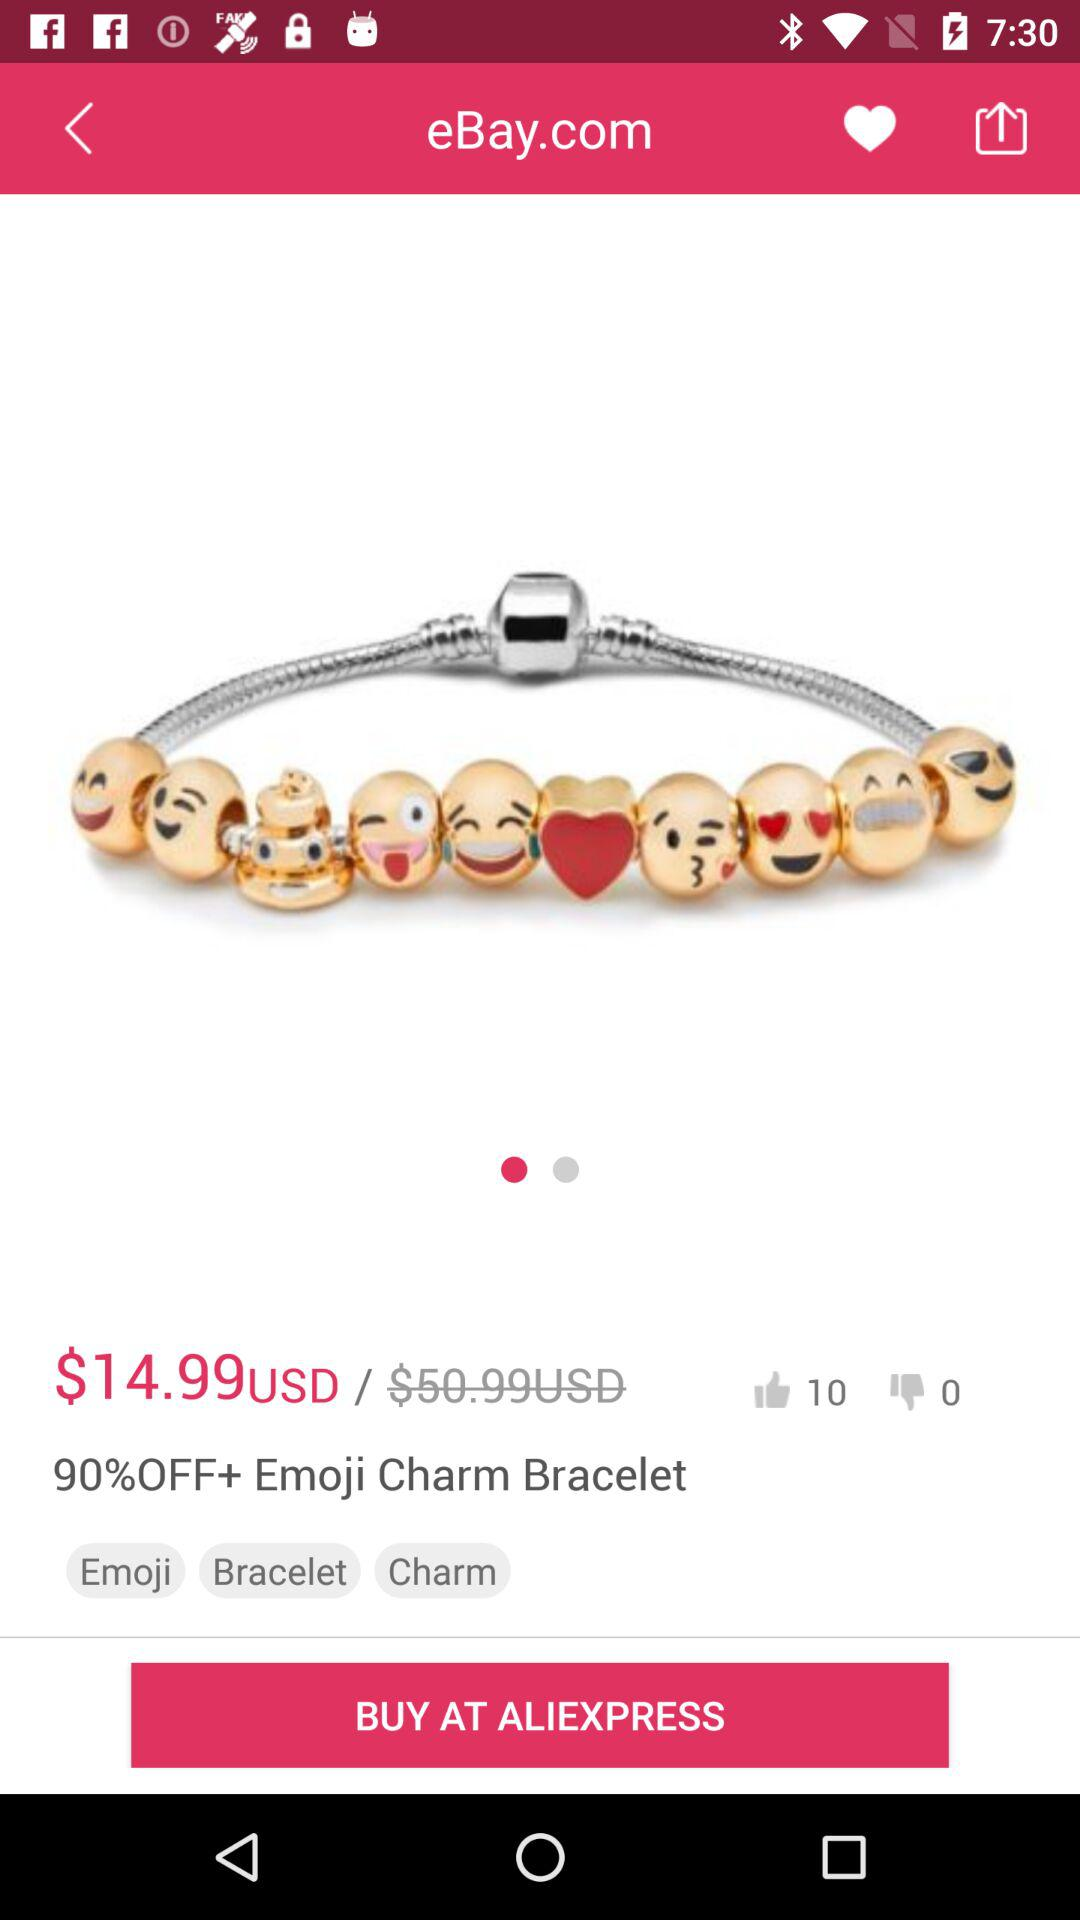How many thumbs up does this product have?
Answer the question using a single word or phrase. 10 